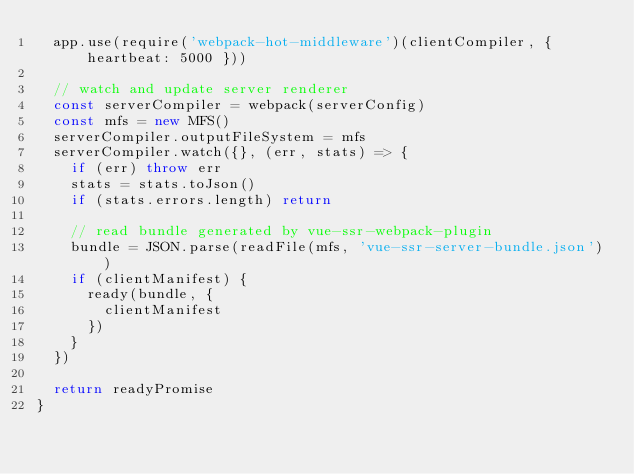<code> <loc_0><loc_0><loc_500><loc_500><_JavaScript_>  app.use(require('webpack-hot-middleware')(clientCompiler, { heartbeat: 5000 }))

  // watch and update server renderer
  const serverCompiler = webpack(serverConfig)
  const mfs = new MFS()
  serverCompiler.outputFileSystem = mfs
  serverCompiler.watch({}, (err, stats) => {
    if (err) throw err
    stats = stats.toJson()
    if (stats.errors.length) return

    // read bundle generated by vue-ssr-webpack-plugin
    bundle = JSON.parse(readFile(mfs, 'vue-ssr-server-bundle.json'))
    if (clientManifest) {
      ready(bundle, {
        clientManifest
      })
    }
  })

  return readyPromise
}
</code> 